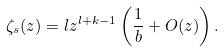Convert formula to latex. <formula><loc_0><loc_0><loc_500><loc_500>\zeta _ { s } ( z ) = l z ^ { l + k - 1 } \left ( \frac { 1 } { b } + O ( z ) \right ) .</formula> 